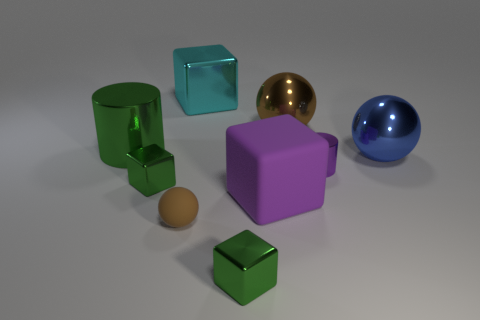Subtract 1 cubes. How many cubes are left? 3 Subtract all cylinders. How many objects are left? 7 Subtract 0 cyan cylinders. How many objects are left? 9 Subtract all tiny brown objects. Subtract all purple metallic objects. How many objects are left? 7 Add 7 small purple things. How many small purple things are left? 8 Add 6 shiny balls. How many shiny balls exist? 8 